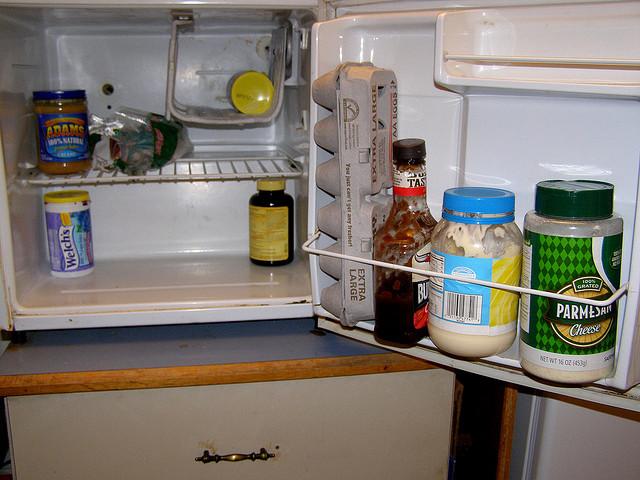What would you sprinkle on spaghetti?
Give a very brief answer. Parmesan cheese. Where is the egg carton?
Be succinct. Door. Is there water here?
Keep it brief. No. What type of vitamin is in the fridge?
Write a very short answer. B. 